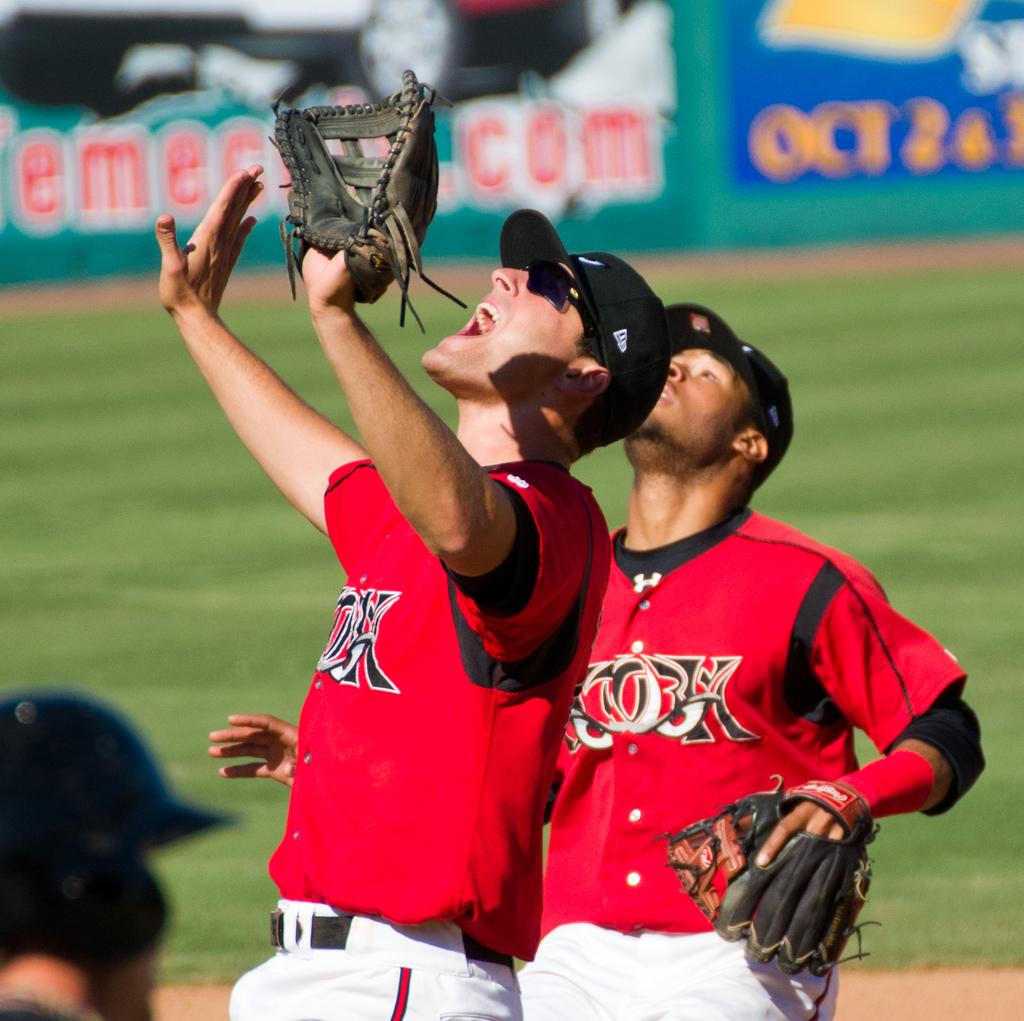How many people are in the image? There are three persons in the image. What is the surface behind the persons made of? There is grass on the surface behind the persons. Can you describe anything on the backside of the image? Yes, there is a banner on the backside of the image. What type of liquid can be seen dripping from the branch in the image? There is no branch or liquid present in the image. 